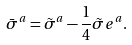Convert formula to latex. <formula><loc_0><loc_0><loc_500><loc_500>\bar { \sigma } ^ { a } = \tilde { \sigma } ^ { a } - \frac { 1 } { 4 } \tilde { \sigma } e ^ { a } .</formula> 